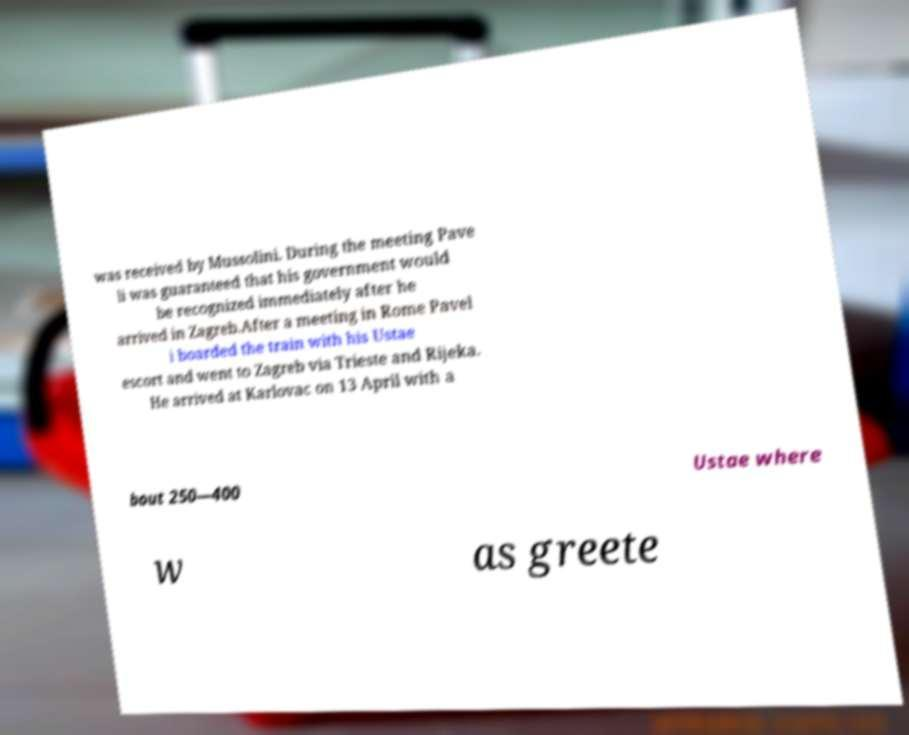I need the written content from this picture converted into text. Can you do that? was received by Mussolini. During the meeting Pave li was guaranteed that his government would be recognized immediately after he arrived in Zagreb.After a meeting in Rome Pavel i boarded the train with his Ustae escort and went to Zagreb via Trieste and Rijeka. He arrived at Karlovac on 13 April with a bout 250—400 Ustae where w as greete 